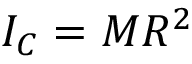<formula> <loc_0><loc_0><loc_500><loc_500>I _ { C } = M R ^ { 2 }</formula> 